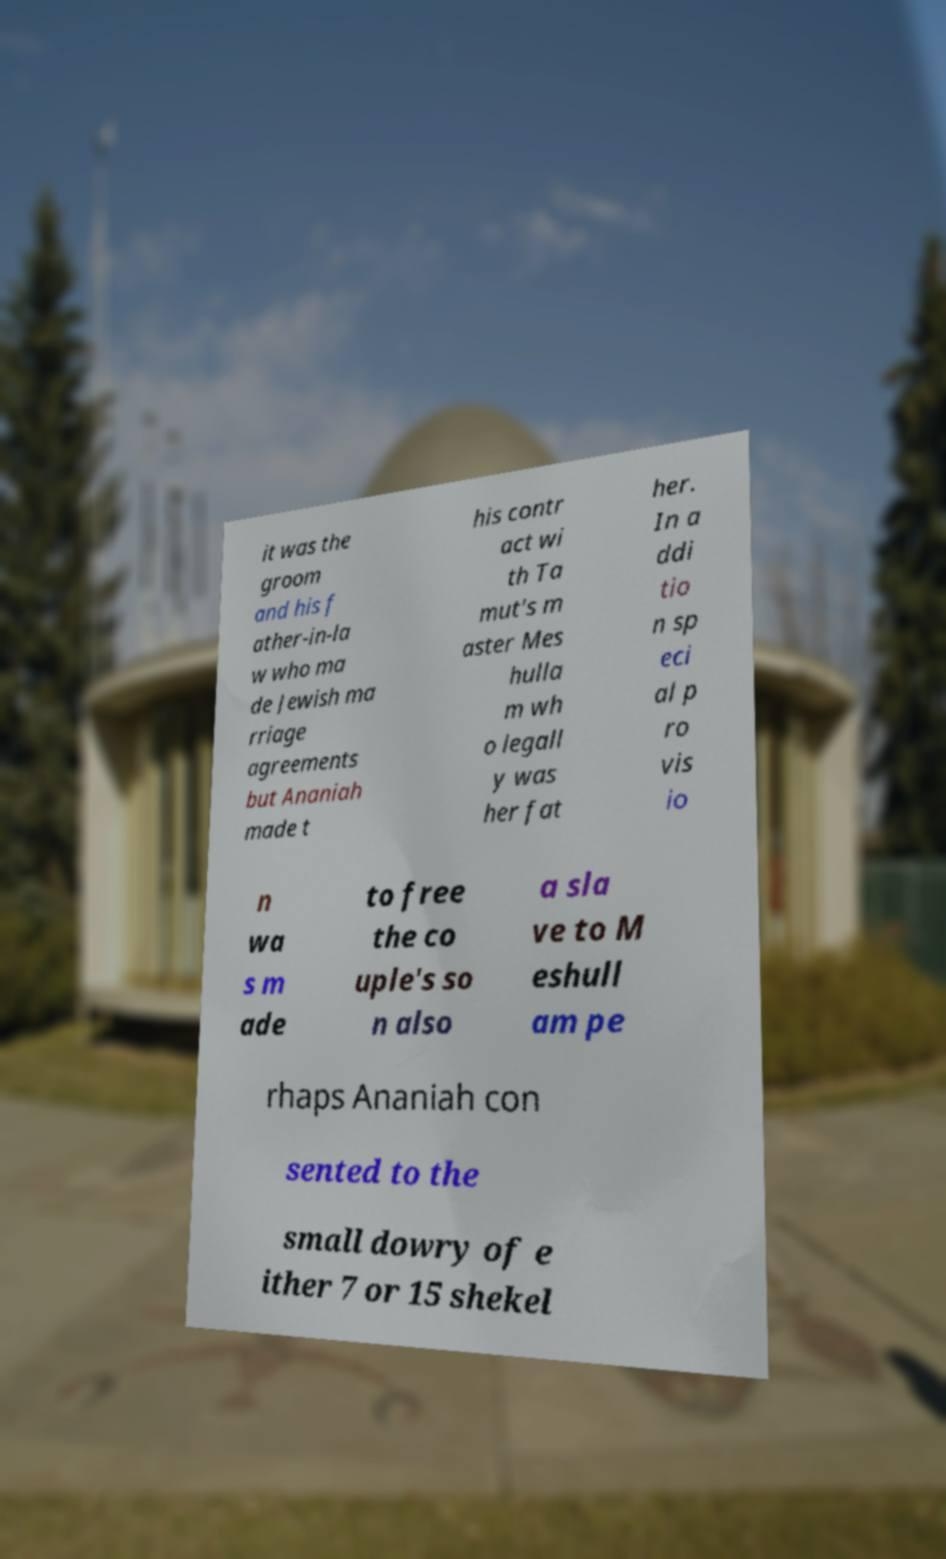For documentation purposes, I need the text within this image transcribed. Could you provide that? it was the groom and his f ather-in-la w who ma de Jewish ma rriage agreements but Ananiah made t his contr act wi th Ta mut's m aster Mes hulla m wh o legall y was her fat her. In a ddi tio n sp eci al p ro vis io n wa s m ade to free the co uple's so n also a sla ve to M eshull am pe rhaps Ananiah con sented to the small dowry of e ither 7 or 15 shekel 